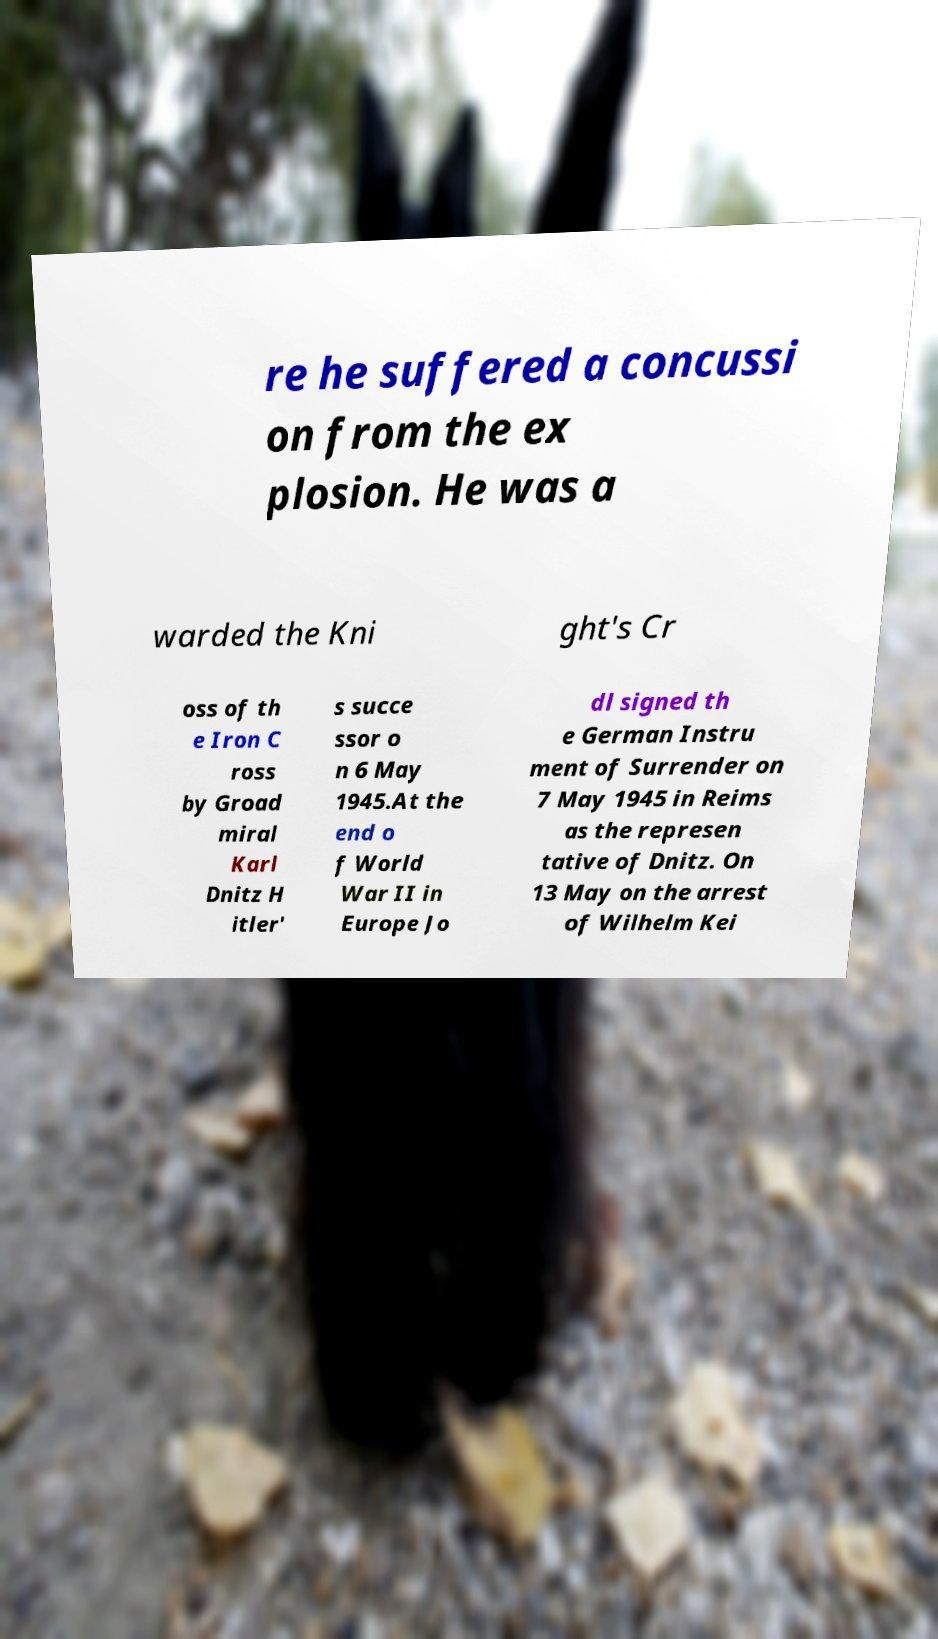Can you read and provide the text displayed in the image?This photo seems to have some interesting text. Can you extract and type it out for me? re he suffered a concussi on from the ex plosion. He was a warded the Kni ght's Cr oss of th e Iron C ross by Groad miral Karl Dnitz H itler' s succe ssor o n 6 May 1945.At the end o f World War II in Europe Jo dl signed th e German Instru ment of Surrender on 7 May 1945 in Reims as the represen tative of Dnitz. On 13 May on the arrest of Wilhelm Kei 